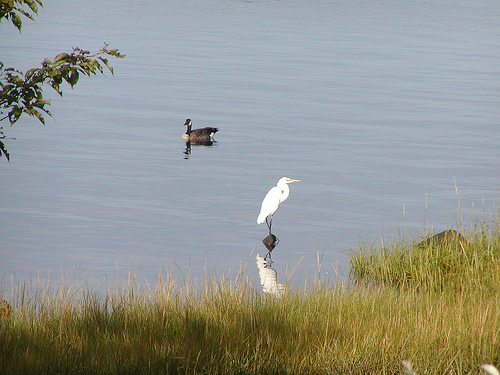<image>
Is there a bird above the water? Yes. The bird is positioned above the water in the vertical space, higher up in the scene. 